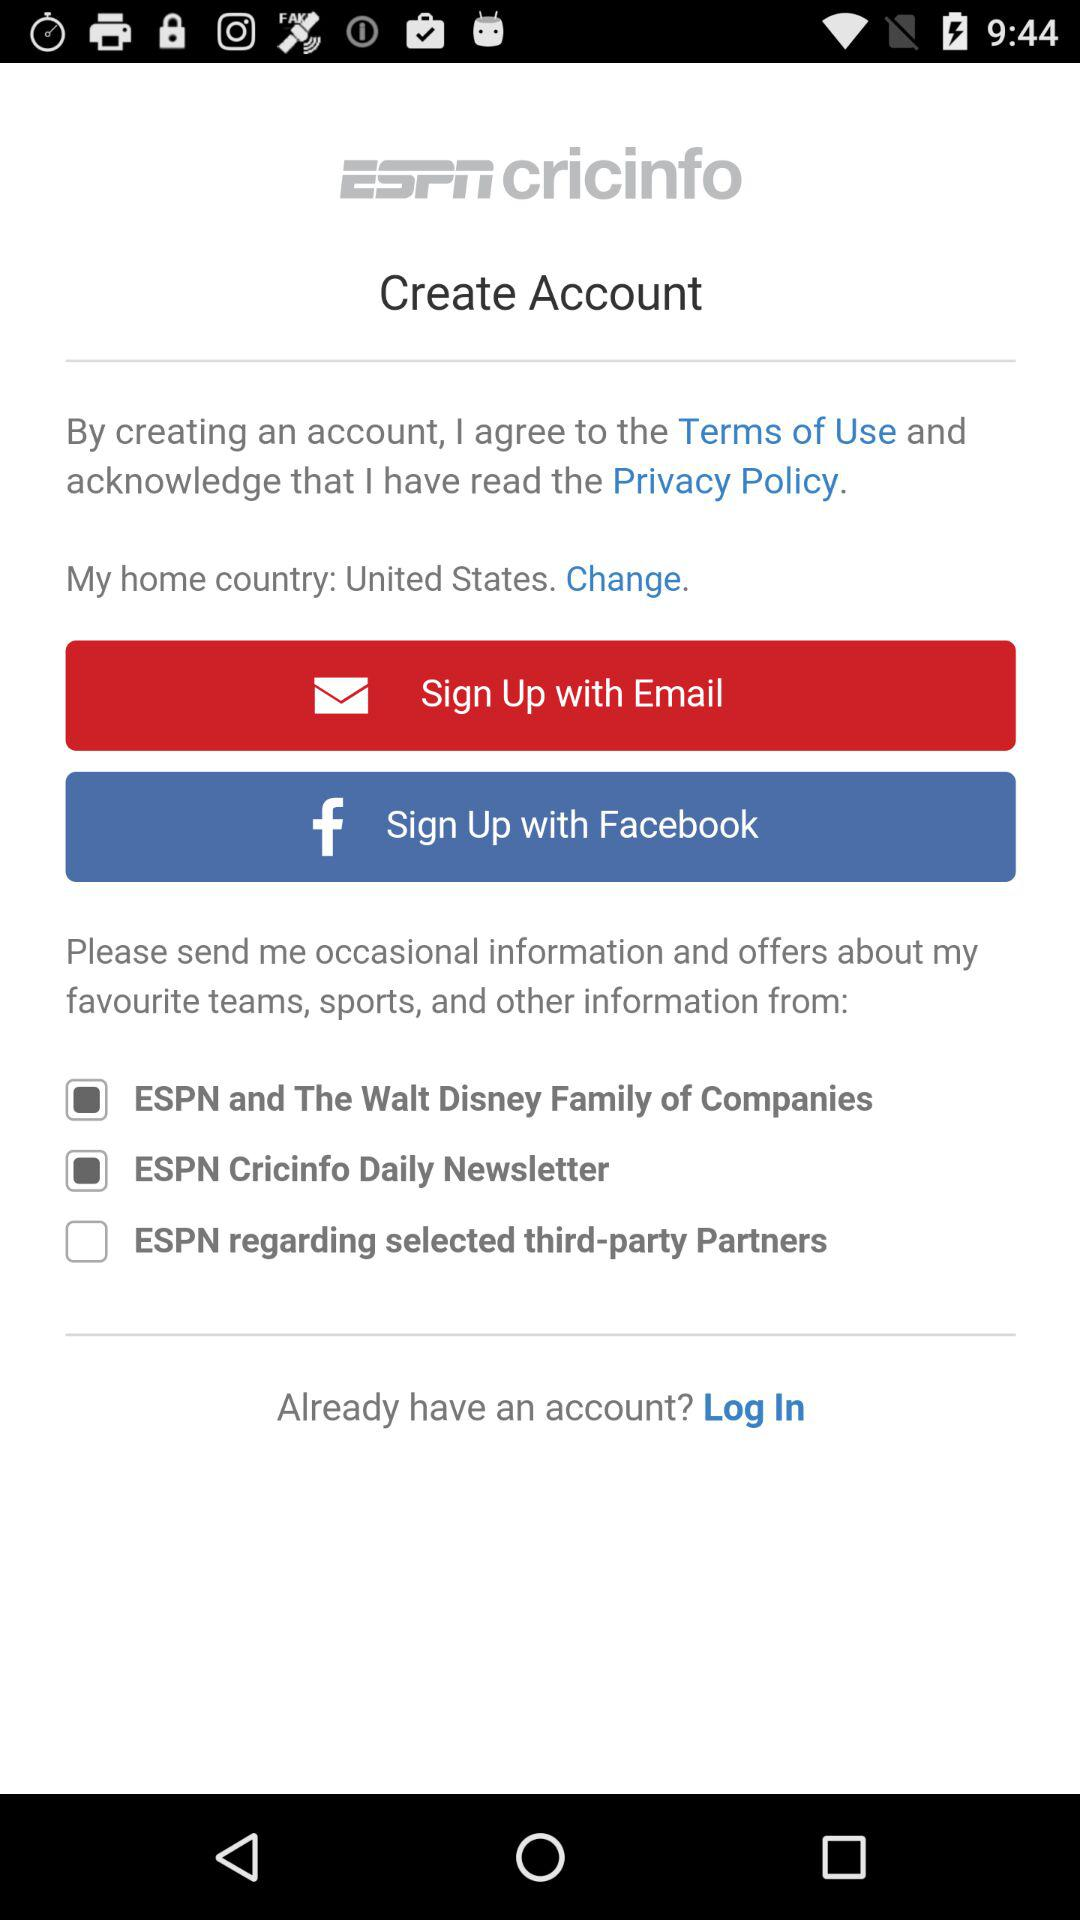What is the current status of the "ESPN and The Walt Disney Family of Companies"? The current status is "on". 